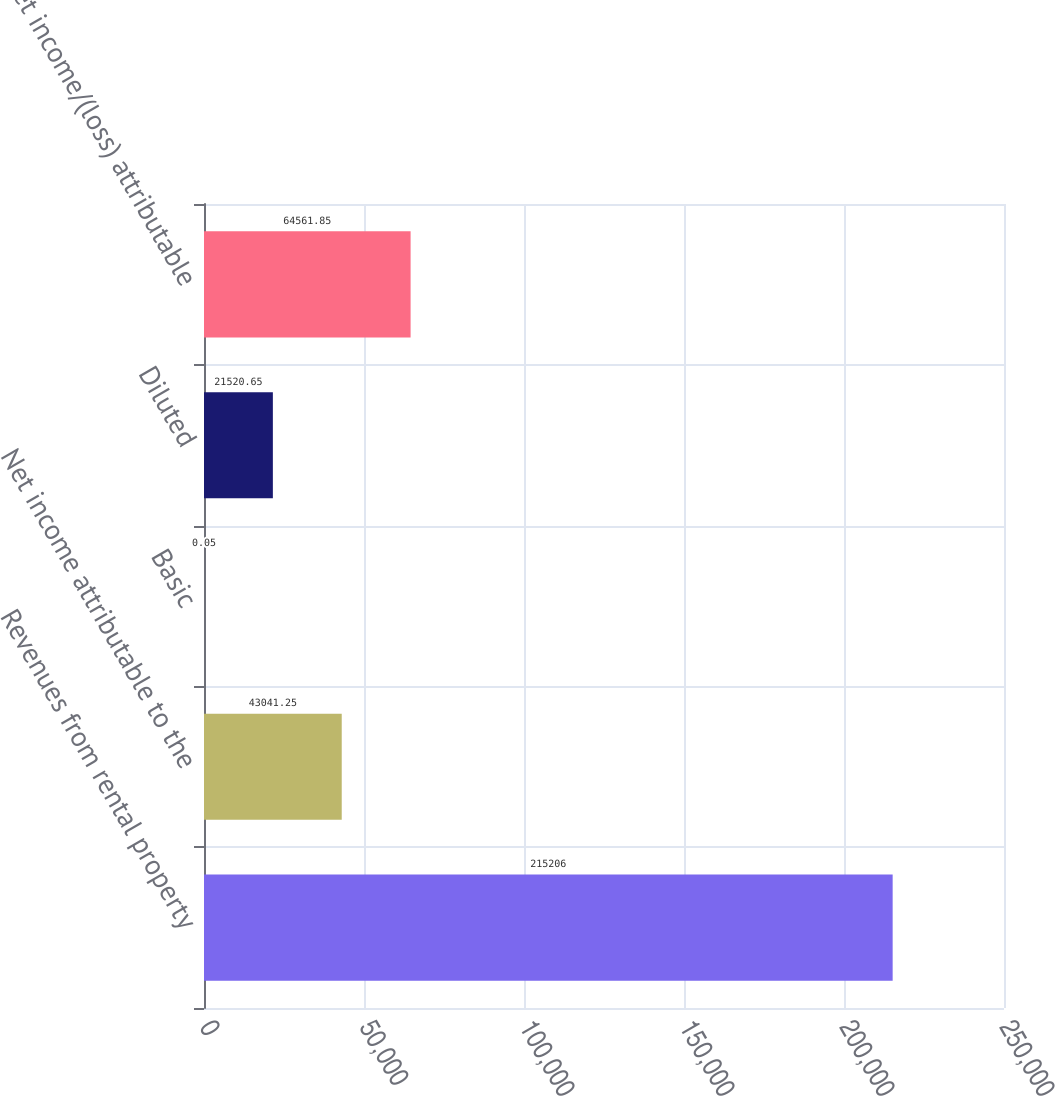Convert chart. <chart><loc_0><loc_0><loc_500><loc_500><bar_chart><fcel>Revenues from rental property<fcel>Net income attributable to the<fcel>Basic<fcel>Diluted<fcel>Net income/(loss) attributable<nl><fcel>215206<fcel>43041.2<fcel>0.05<fcel>21520.7<fcel>64561.8<nl></chart> 